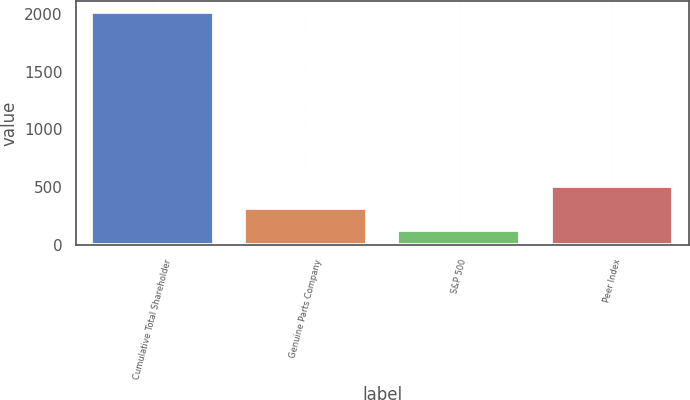Convert chart to OTSL. <chart><loc_0><loc_0><loc_500><loc_500><bar_chart><fcel>Cumulative Total Shareholder<fcel>Genuine Parts Company<fcel>S&P 500<fcel>Peer Index<nl><fcel>2013<fcel>320.45<fcel>132.39<fcel>508.51<nl></chart> 